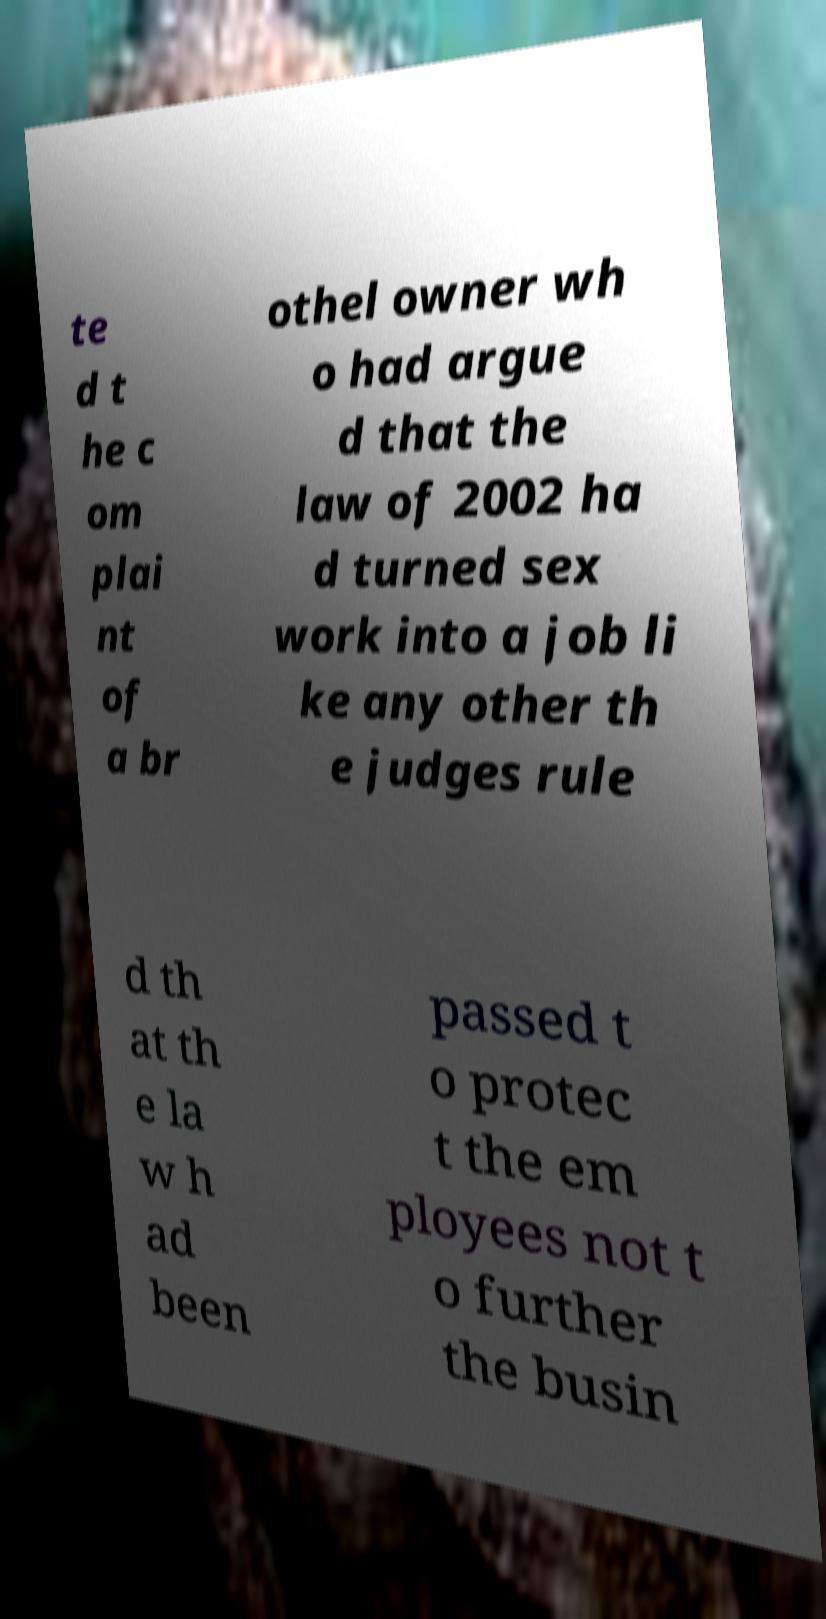Please identify and transcribe the text found in this image. te d t he c om plai nt of a br othel owner wh o had argue d that the law of 2002 ha d turned sex work into a job li ke any other th e judges rule d th at th e la w h ad been passed t o protec t the em ployees not t o further the busin 